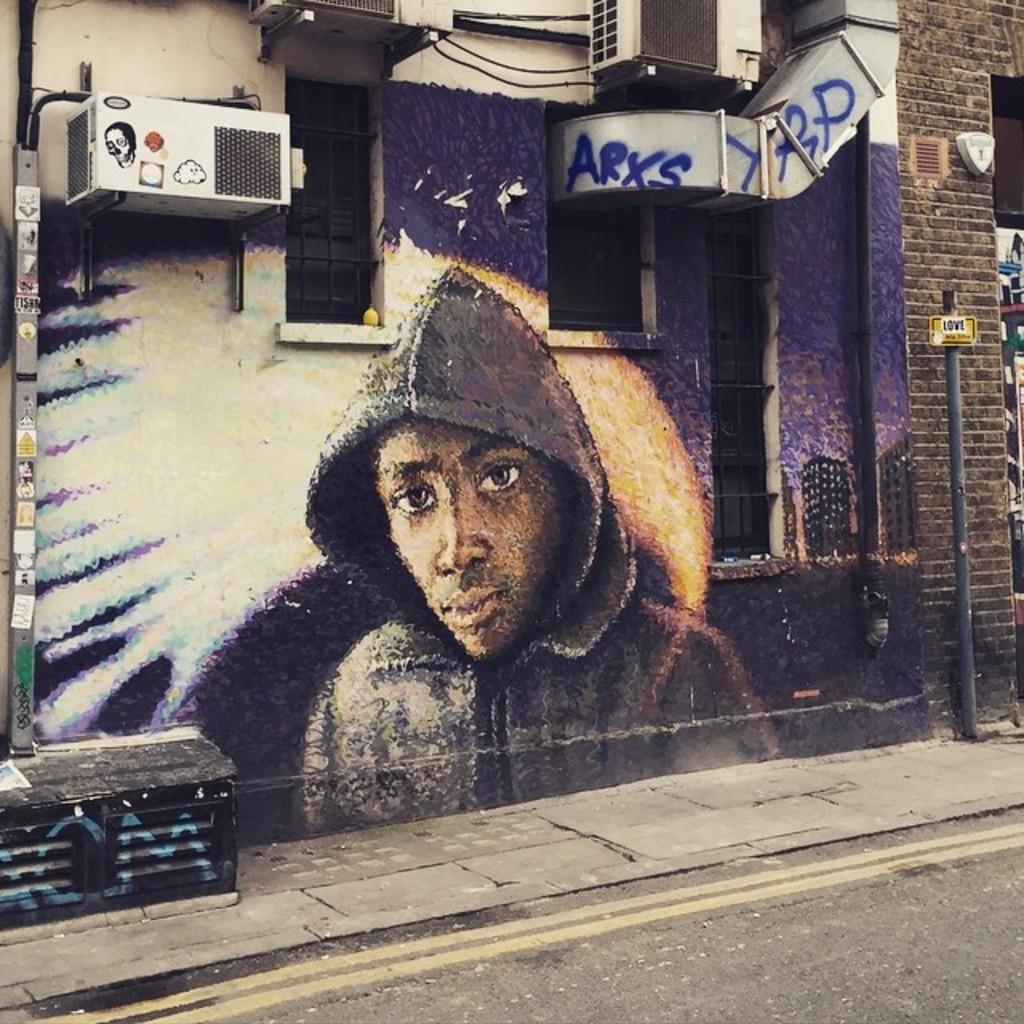Can you describe this image briefly? In this picture I can see the painting of a man which is painted on the wall. On the wall I can see the ducts and exhaustive machines. On the right I can see the black pole near to the brick wall. At the bottom there is a road. 